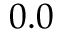<formula> <loc_0><loc_0><loc_500><loc_500>0 . 0</formula> 